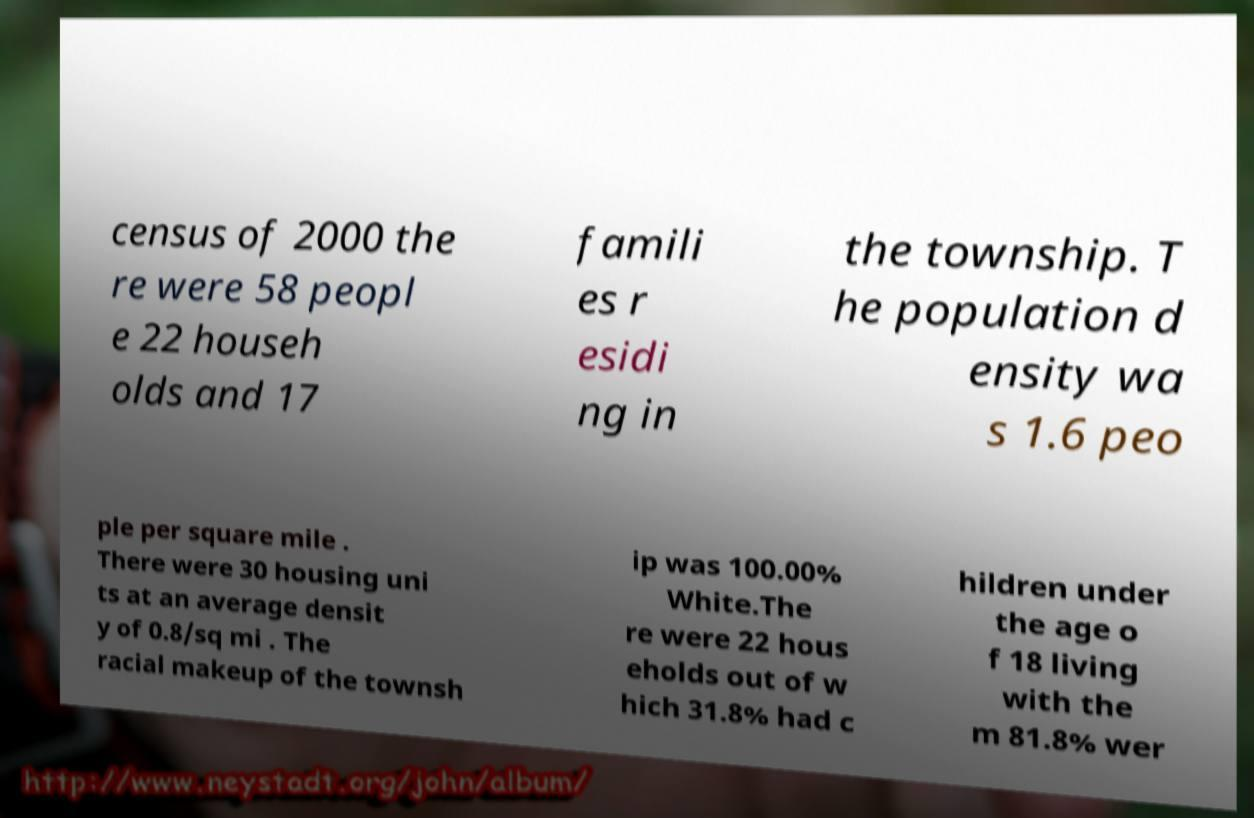I need the written content from this picture converted into text. Can you do that? census of 2000 the re were 58 peopl e 22 househ olds and 17 famili es r esidi ng in the township. T he population d ensity wa s 1.6 peo ple per square mile . There were 30 housing uni ts at an average densit y of 0.8/sq mi . The racial makeup of the townsh ip was 100.00% White.The re were 22 hous eholds out of w hich 31.8% had c hildren under the age o f 18 living with the m 81.8% wer 